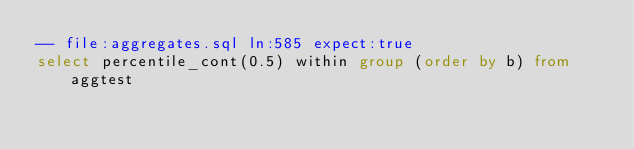Convert code to text. <code><loc_0><loc_0><loc_500><loc_500><_SQL_>-- file:aggregates.sql ln:585 expect:true
select percentile_cont(0.5) within group (order by b) from aggtest
</code> 